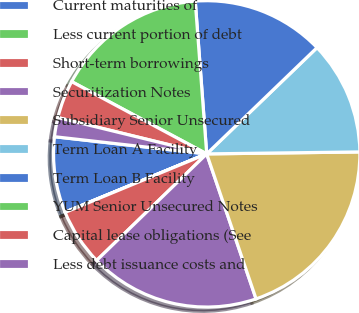Convert chart to OTSL. <chart><loc_0><loc_0><loc_500><loc_500><pie_chart><fcel>Current maturities of<fcel>Less current portion of debt<fcel>Short-term borrowings<fcel>Securitization Notes<fcel>Subsidiary Senior Unsecured<fcel>Term Loan A Facility<fcel>Term Loan B Facility<fcel>YUM Senior Unsecured Notes<fcel>Capital lease obligations (See<fcel>Less debt issuance costs and<nl><fcel>8.0%<fcel>0.02%<fcel>6.01%<fcel>17.98%<fcel>19.98%<fcel>12.0%<fcel>13.99%<fcel>15.99%<fcel>4.01%<fcel>2.02%<nl></chart> 